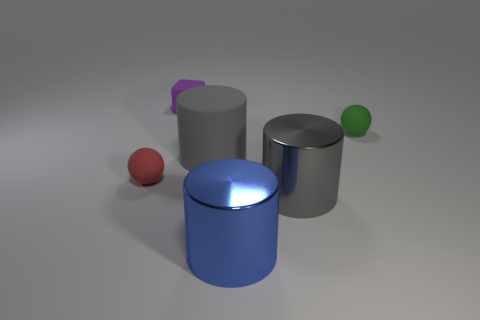Add 2 green spheres. How many objects exist? 8 Subtract all balls. How many objects are left? 4 Add 1 blocks. How many blocks exist? 2 Subtract 0 blue cubes. How many objects are left? 6 Subtract all tiny purple blocks. Subtract all red objects. How many objects are left? 4 Add 6 rubber cubes. How many rubber cubes are left? 7 